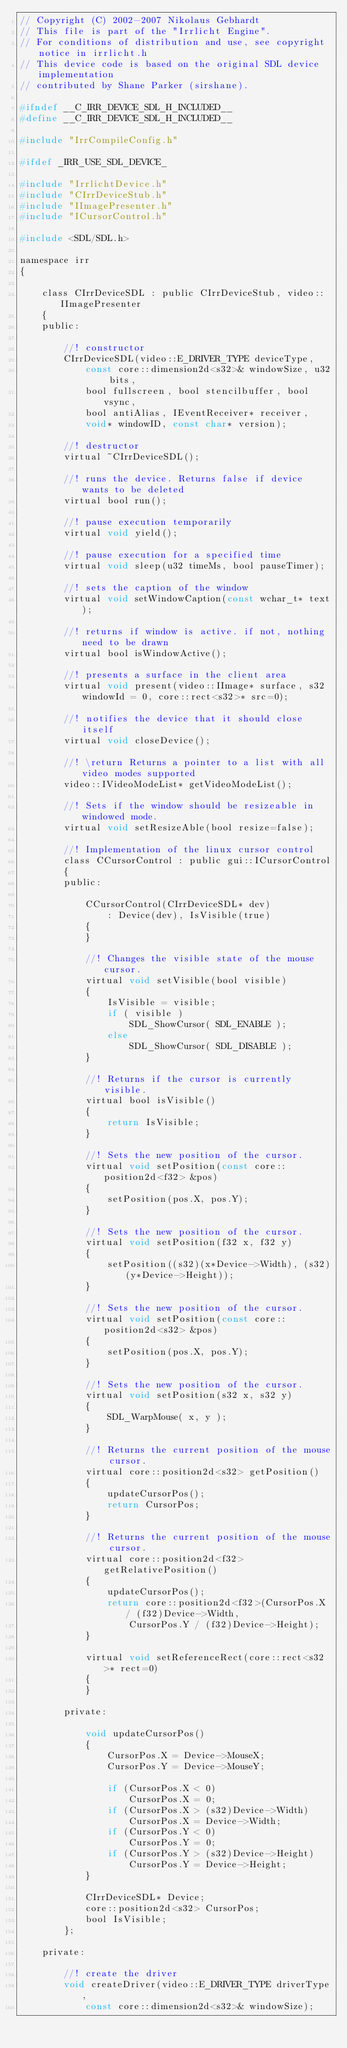Convert code to text. <code><loc_0><loc_0><loc_500><loc_500><_C_>// Copyright (C) 2002-2007 Nikolaus Gebhardt
// This file is part of the "Irrlicht Engine".
// For conditions of distribution and use, see copyright notice in irrlicht.h
// This device code is based on the original SDL device implementation
// contributed by Shane Parker (sirshane).

#ifndef __C_IRR_DEVICE_SDL_H_INCLUDED__
#define __C_IRR_DEVICE_SDL_H_INCLUDED__

#include "IrrCompileConfig.h"

#ifdef _IRR_USE_SDL_DEVICE_

#include "IrrlichtDevice.h"
#include "CIrrDeviceStub.h"
#include "IImagePresenter.h"
#include "ICursorControl.h"

#include <SDL/SDL.h>

namespace irr
{

	class CIrrDeviceSDL : public CIrrDeviceStub, video::IImagePresenter
	{
	public:

		//! constructor
		CIrrDeviceSDL(video::E_DRIVER_TYPE deviceType, 
			const core::dimension2d<s32>& windowSize, u32 bits,
			bool fullscreen, bool stencilbuffer, bool vsync,
			bool antiAlias, IEventReceiver* receiver,
			void* windowID, const char* version);

		//! destructor
		virtual ~CIrrDeviceSDL();

		//! runs the device. Returns false if device wants to be deleted
		virtual bool run();

		//! pause execution temporarily
		virtual void yield();

		//! pause execution for a specified time
		virtual void sleep(u32 timeMs, bool pauseTimer);

		//! sets the caption of the window
		virtual void setWindowCaption(const wchar_t* text);

		//! returns if window is active. if not, nothing need to be drawn
		virtual bool isWindowActive();

		//! presents a surface in the client area
		virtual void present(video::IImage* surface, s32 windowId = 0, core::rect<s32>* src=0);

		//! notifies the device that it should close itself
		virtual void closeDevice();

		//! \return Returns a pointer to a list with all video modes supported
		video::IVideoModeList* getVideoModeList();

		//! Sets if the window should be resizeable in windowed mode.
		virtual void setResizeAble(bool resize=false);

		//! Implementation of the linux cursor control
		class CCursorControl : public gui::ICursorControl
		{
		public:

			CCursorControl(CIrrDeviceSDL* dev)
				: Device(dev), IsVisible(true)
			{
			}

			//! Changes the visible state of the mouse cursor.
			virtual void setVisible(bool visible)
			{
				IsVisible = visible;
				if ( visible )
					SDL_ShowCursor( SDL_ENABLE );
				else
					SDL_ShowCursor( SDL_DISABLE );
			}

			//! Returns if the cursor is currently visible.
			virtual bool isVisible()
			{
				return IsVisible;
			}

			//! Sets the new position of the cursor.
			virtual void setPosition(const core::position2d<f32> &pos)
			{
				setPosition(pos.X, pos.Y);
			}

			//! Sets the new position of the cursor.
			virtual void setPosition(f32 x, f32 y)
			{
				setPosition((s32)(x*Device->Width), (s32)(y*Device->Height));
			}

			//! Sets the new position of the cursor.
			virtual void setPosition(const core::position2d<s32> &pos)
			{
				setPosition(pos.X, pos.Y);
			}

			//! Sets the new position of the cursor.
			virtual void setPosition(s32 x, s32 y)
			{
				SDL_WarpMouse( x, y );
			}

			//! Returns the current position of the mouse cursor.
			virtual core::position2d<s32> getPosition()
			{
				updateCursorPos();
				return CursorPos;
			}

			//! Returns the current position of the mouse cursor.
			virtual core::position2d<f32> getRelativePosition()
			{
				updateCursorPos();
				return core::position2d<f32>(CursorPos.X / (f32)Device->Width,
					CursorPos.Y / (f32)Device->Height);
			}

			virtual void setReferenceRect(core::rect<s32>* rect=0)
			{
			}

		private:

			void updateCursorPos()
			{
				CursorPos.X = Device->MouseX;
				CursorPos.Y = Device->MouseY;
			
				if (CursorPos.X < 0)
					CursorPos.X = 0;
				if (CursorPos.X > (s32)Device->Width)
					CursorPos.X = Device->Width;
				if (CursorPos.Y < 0)
					CursorPos.Y = 0;
				if (CursorPos.Y > (s32)Device->Height)
					CursorPos.Y = Device->Height;
			}

			CIrrDeviceSDL* Device;
			core::position2d<s32> CursorPos;
			bool IsVisible;
		};

	private:

		//! create the driver
		void createDriver(video::E_DRIVER_TYPE driverType,
			const core::dimension2d<s32>& windowSize);
</code> 